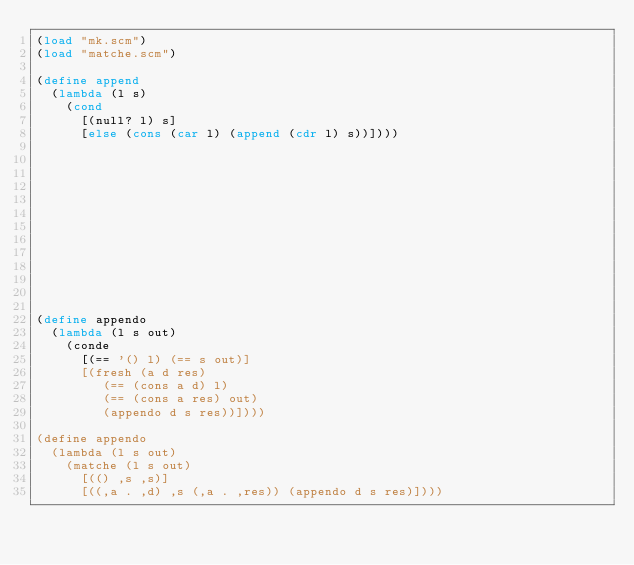<code> <loc_0><loc_0><loc_500><loc_500><_Scheme_>(load "mk.scm")
(load "matche.scm")

(define append
  (lambda (l s)
    (cond
      [(null? l) s]
      [else (cons (car l) (append (cdr l) s))])))













(define appendo
  (lambda (l s out)
    (conde
      [(== '() l) (== s out)]
      [(fresh (a d res)
         (== (cons a d) l)
         (== (cons a res) out)
         (appendo d s res))])))

(define appendo
  (lambda (l s out)
    (matche (l s out)
      [(() ,s ,s)]
      [((,a . ,d) ,s (,a . ,res)) (appendo d s res)])))
</code> 